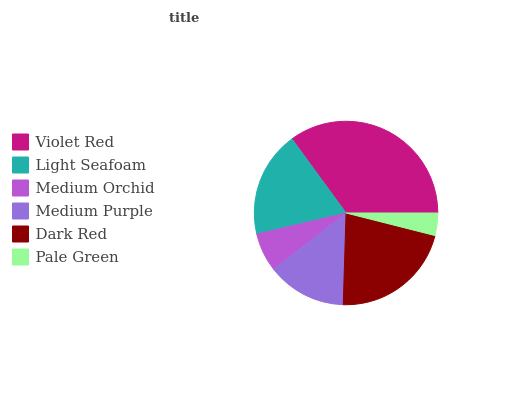Is Pale Green the minimum?
Answer yes or no. Yes. Is Violet Red the maximum?
Answer yes or no. Yes. Is Light Seafoam the minimum?
Answer yes or no. No. Is Light Seafoam the maximum?
Answer yes or no. No. Is Violet Red greater than Light Seafoam?
Answer yes or no. Yes. Is Light Seafoam less than Violet Red?
Answer yes or no. Yes. Is Light Seafoam greater than Violet Red?
Answer yes or no. No. Is Violet Red less than Light Seafoam?
Answer yes or no. No. Is Light Seafoam the high median?
Answer yes or no. Yes. Is Medium Purple the low median?
Answer yes or no. Yes. Is Pale Green the high median?
Answer yes or no. No. Is Medium Orchid the low median?
Answer yes or no. No. 